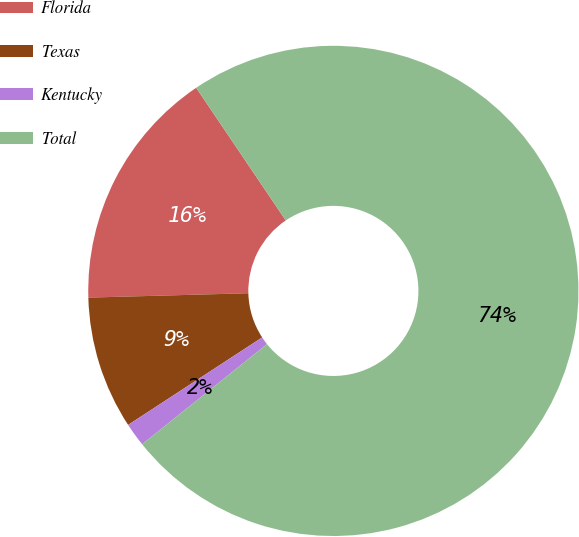Convert chart to OTSL. <chart><loc_0><loc_0><loc_500><loc_500><pie_chart><fcel>Florida<fcel>Texas<fcel>Kentucky<fcel>Total<nl><fcel>15.98%<fcel>8.77%<fcel>1.55%<fcel>73.69%<nl></chart> 